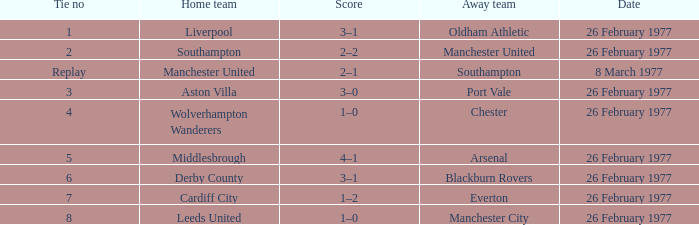What's the result when the wolverhampton wanderers competed at home? 1–0. 